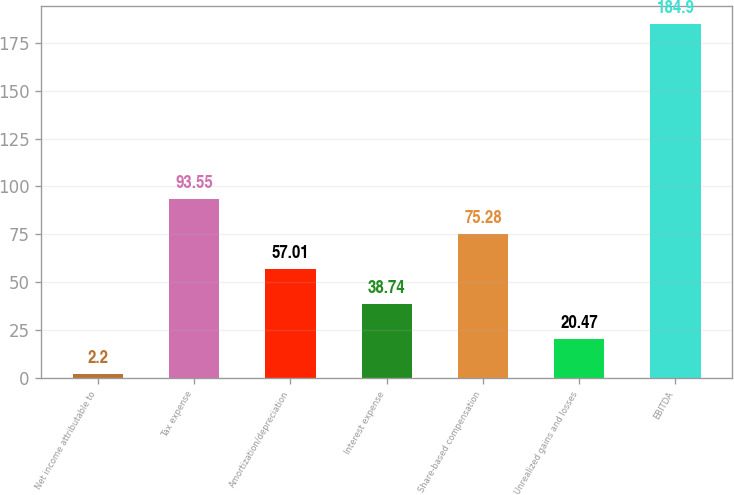Convert chart to OTSL. <chart><loc_0><loc_0><loc_500><loc_500><bar_chart><fcel>Net income attributable to<fcel>Tax expense<fcel>Amortization/depreciation<fcel>Interest expense<fcel>Share-based compensation<fcel>Unrealized gains and losses<fcel>EBITDA<nl><fcel>2.2<fcel>93.55<fcel>57.01<fcel>38.74<fcel>75.28<fcel>20.47<fcel>184.9<nl></chart> 